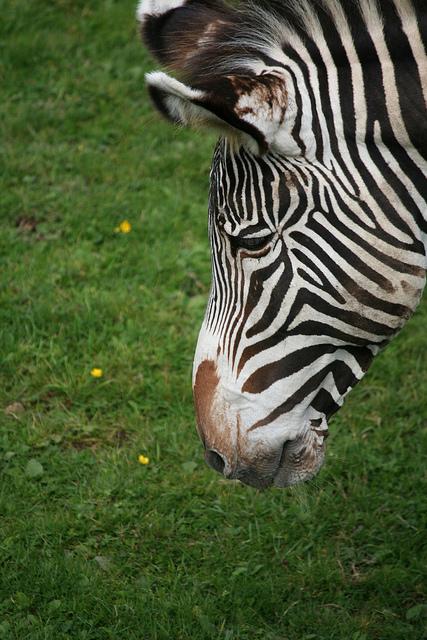Could this animal probably see a lion approaching from it's immediate left?
Quick response, please. Yes. What color is the animal?
Quick response, please. Black and white. How many stripes are there?
Be succinct. 30. What popular saddled animal is this animal closely related to?
Write a very short answer. Horse. What kind of animal has this face?
Keep it brief. Zebra. Is the animal eating?
Keep it brief. Yes. 